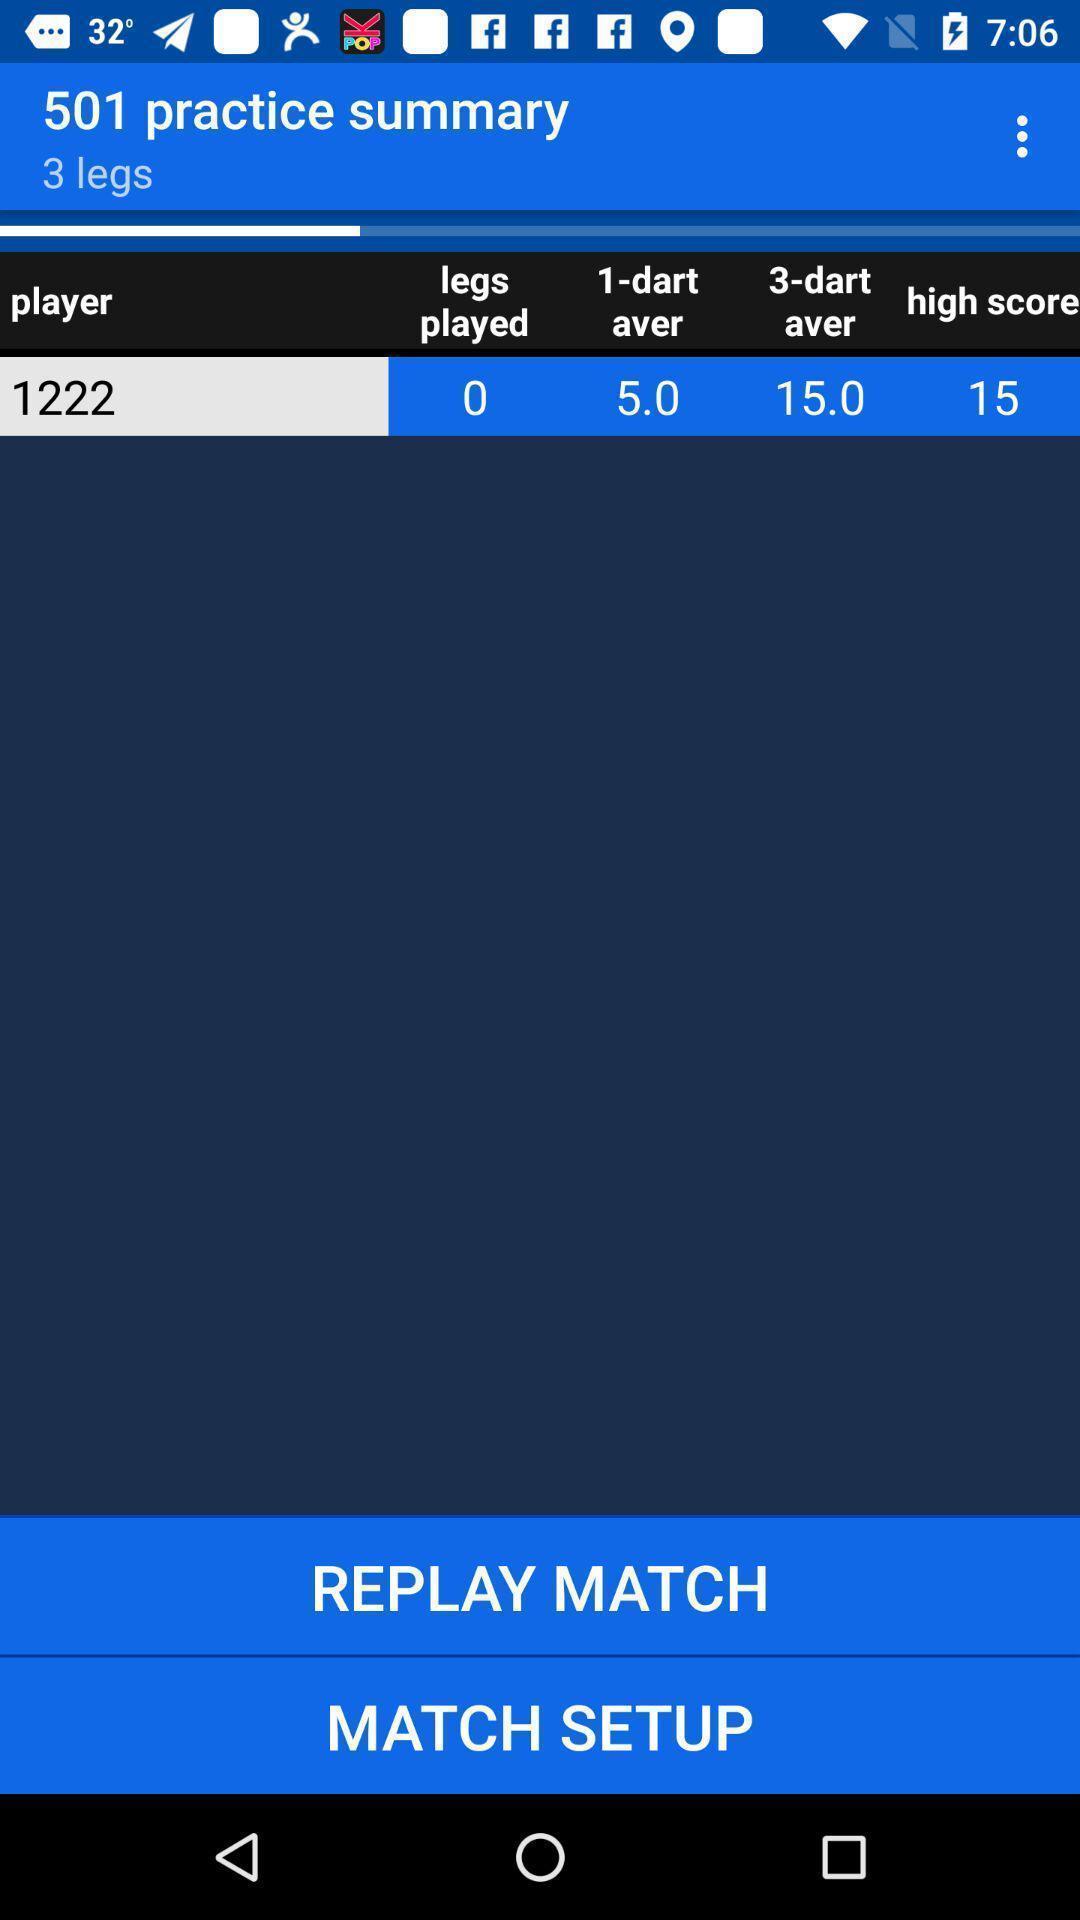Summarize the main components in this picture. Screen showing practice summary with options. 